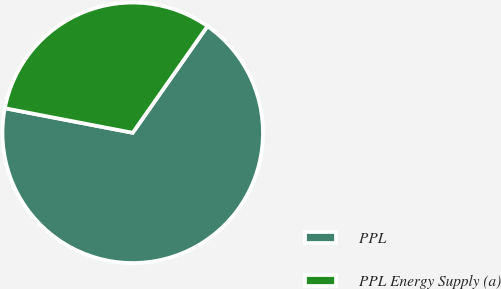Convert chart to OTSL. <chart><loc_0><loc_0><loc_500><loc_500><pie_chart><fcel>PPL<fcel>PPL Energy Supply (a)<nl><fcel>68.29%<fcel>31.71%<nl></chart> 